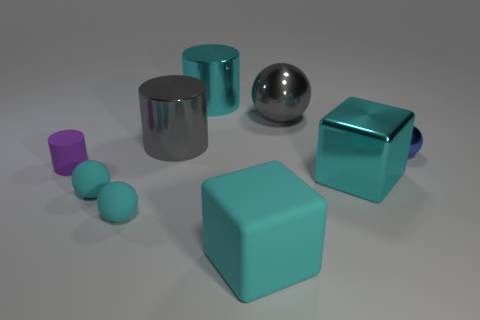There is a cyan shiny thing behind the purple matte cylinder; is its size the same as the cube in front of the shiny cube?
Provide a succinct answer. Yes. What is the size of the cylinder that is in front of the small shiny thing?
Your response must be concise. Small. How big is the cylinder in front of the tiny blue object to the right of the large sphere?
Ensure brevity in your answer.  Small. There is a purple thing that is the same size as the blue metallic thing; what material is it?
Make the answer very short. Rubber. There is a small rubber cylinder; are there any matte things right of it?
Your response must be concise. Yes. Are there an equal number of big gray objects that are left of the cyan shiny cylinder and large cyan blocks?
Keep it short and to the point. No. There is a purple rubber thing that is the same size as the blue object; what is its shape?
Your answer should be very brief. Cylinder. What material is the tiny purple thing?
Your answer should be compact. Rubber. The shiny thing that is both behind the tiny purple rubber thing and on the right side of the large ball is what color?
Provide a succinct answer. Blue. Is the number of blue things that are in front of the blue ball the same as the number of large cyan metallic things in front of the large sphere?
Your answer should be very brief. No. 